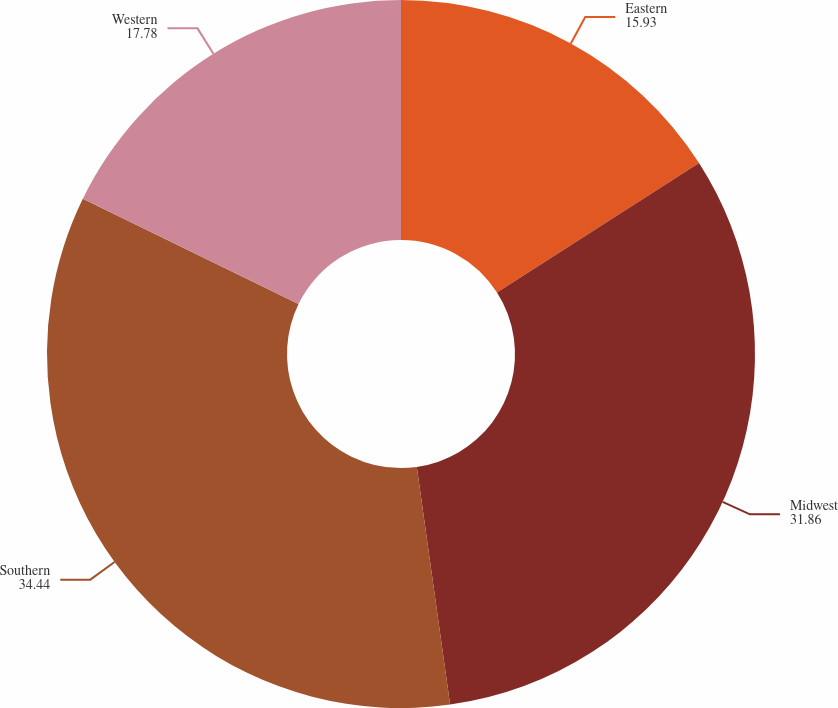<chart> <loc_0><loc_0><loc_500><loc_500><pie_chart><fcel>Eastern<fcel>Midwest<fcel>Southern<fcel>Western<nl><fcel>15.93%<fcel>31.86%<fcel>34.44%<fcel>17.78%<nl></chart> 